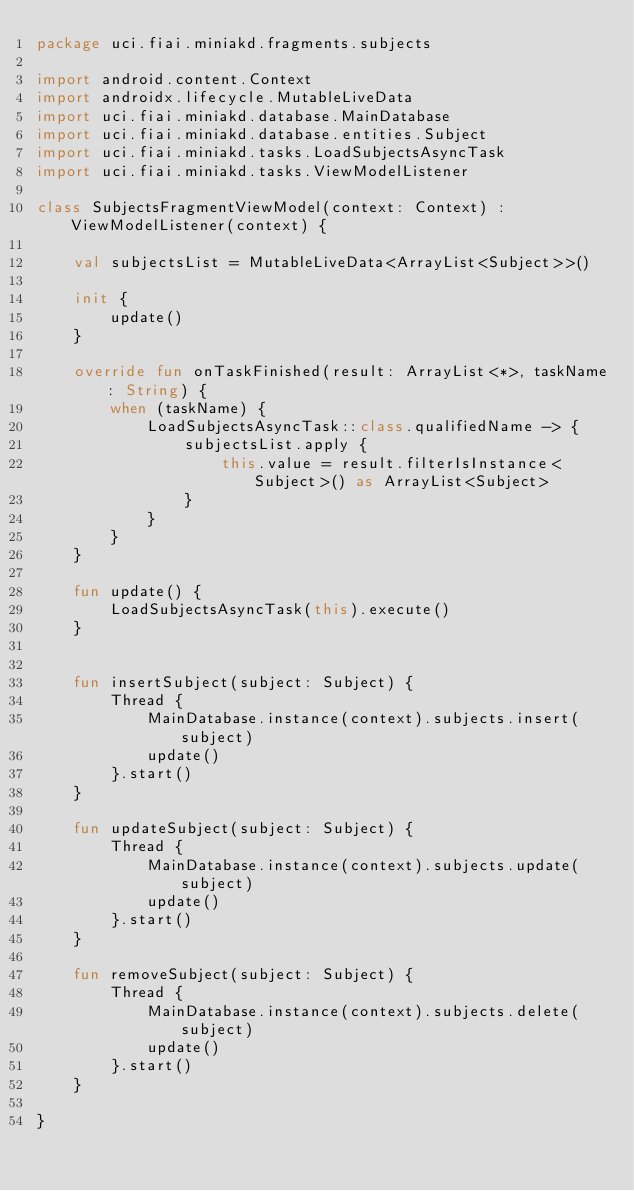Convert code to text. <code><loc_0><loc_0><loc_500><loc_500><_Kotlin_>package uci.fiai.miniakd.fragments.subjects

import android.content.Context
import androidx.lifecycle.MutableLiveData
import uci.fiai.miniakd.database.MainDatabase
import uci.fiai.miniakd.database.entities.Subject
import uci.fiai.miniakd.tasks.LoadSubjectsAsyncTask
import uci.fiai.miniakd.tasks.ViewModelListener

class SubjectsFragmentViewModel(context: Context) : ViewModelListener(context) {

    val subjectsList = MutableLiveData<ArrayList<Subject>>()

    init {
        update()
    }

    override fun onTaskFinished(result: ArrayList<*>, taskName: String) {
        when (taskName) {
            LoadSubjectsAsyncTask::class.qualifiedName -> {
                subjectsList.apply {
                    this.value = result.filterIsInstance<Subject>() as ArrayList<Subject>
                }
            }
        }
    }

    fun update() {
        LoadSubjectsAsyncTask(this).execute()
    }


    fun insertSubject(subject: Subject) {
        Thread {
            MainDatabase.instance(context).subjects.insert(subject)
            update()
        }.start()
    }

    fun updateSubject(subject: Subject) {
        Thread {
            MainDatabase.instance(context).subjects.update(subject)
            update()
        }.start()
    }

    fun removeSubject(subject: Subject) {
        Thread {
            MainDatabase.instance(context).subjects.delete(subject)
            update()
        }.start()
    }

}
</code> 